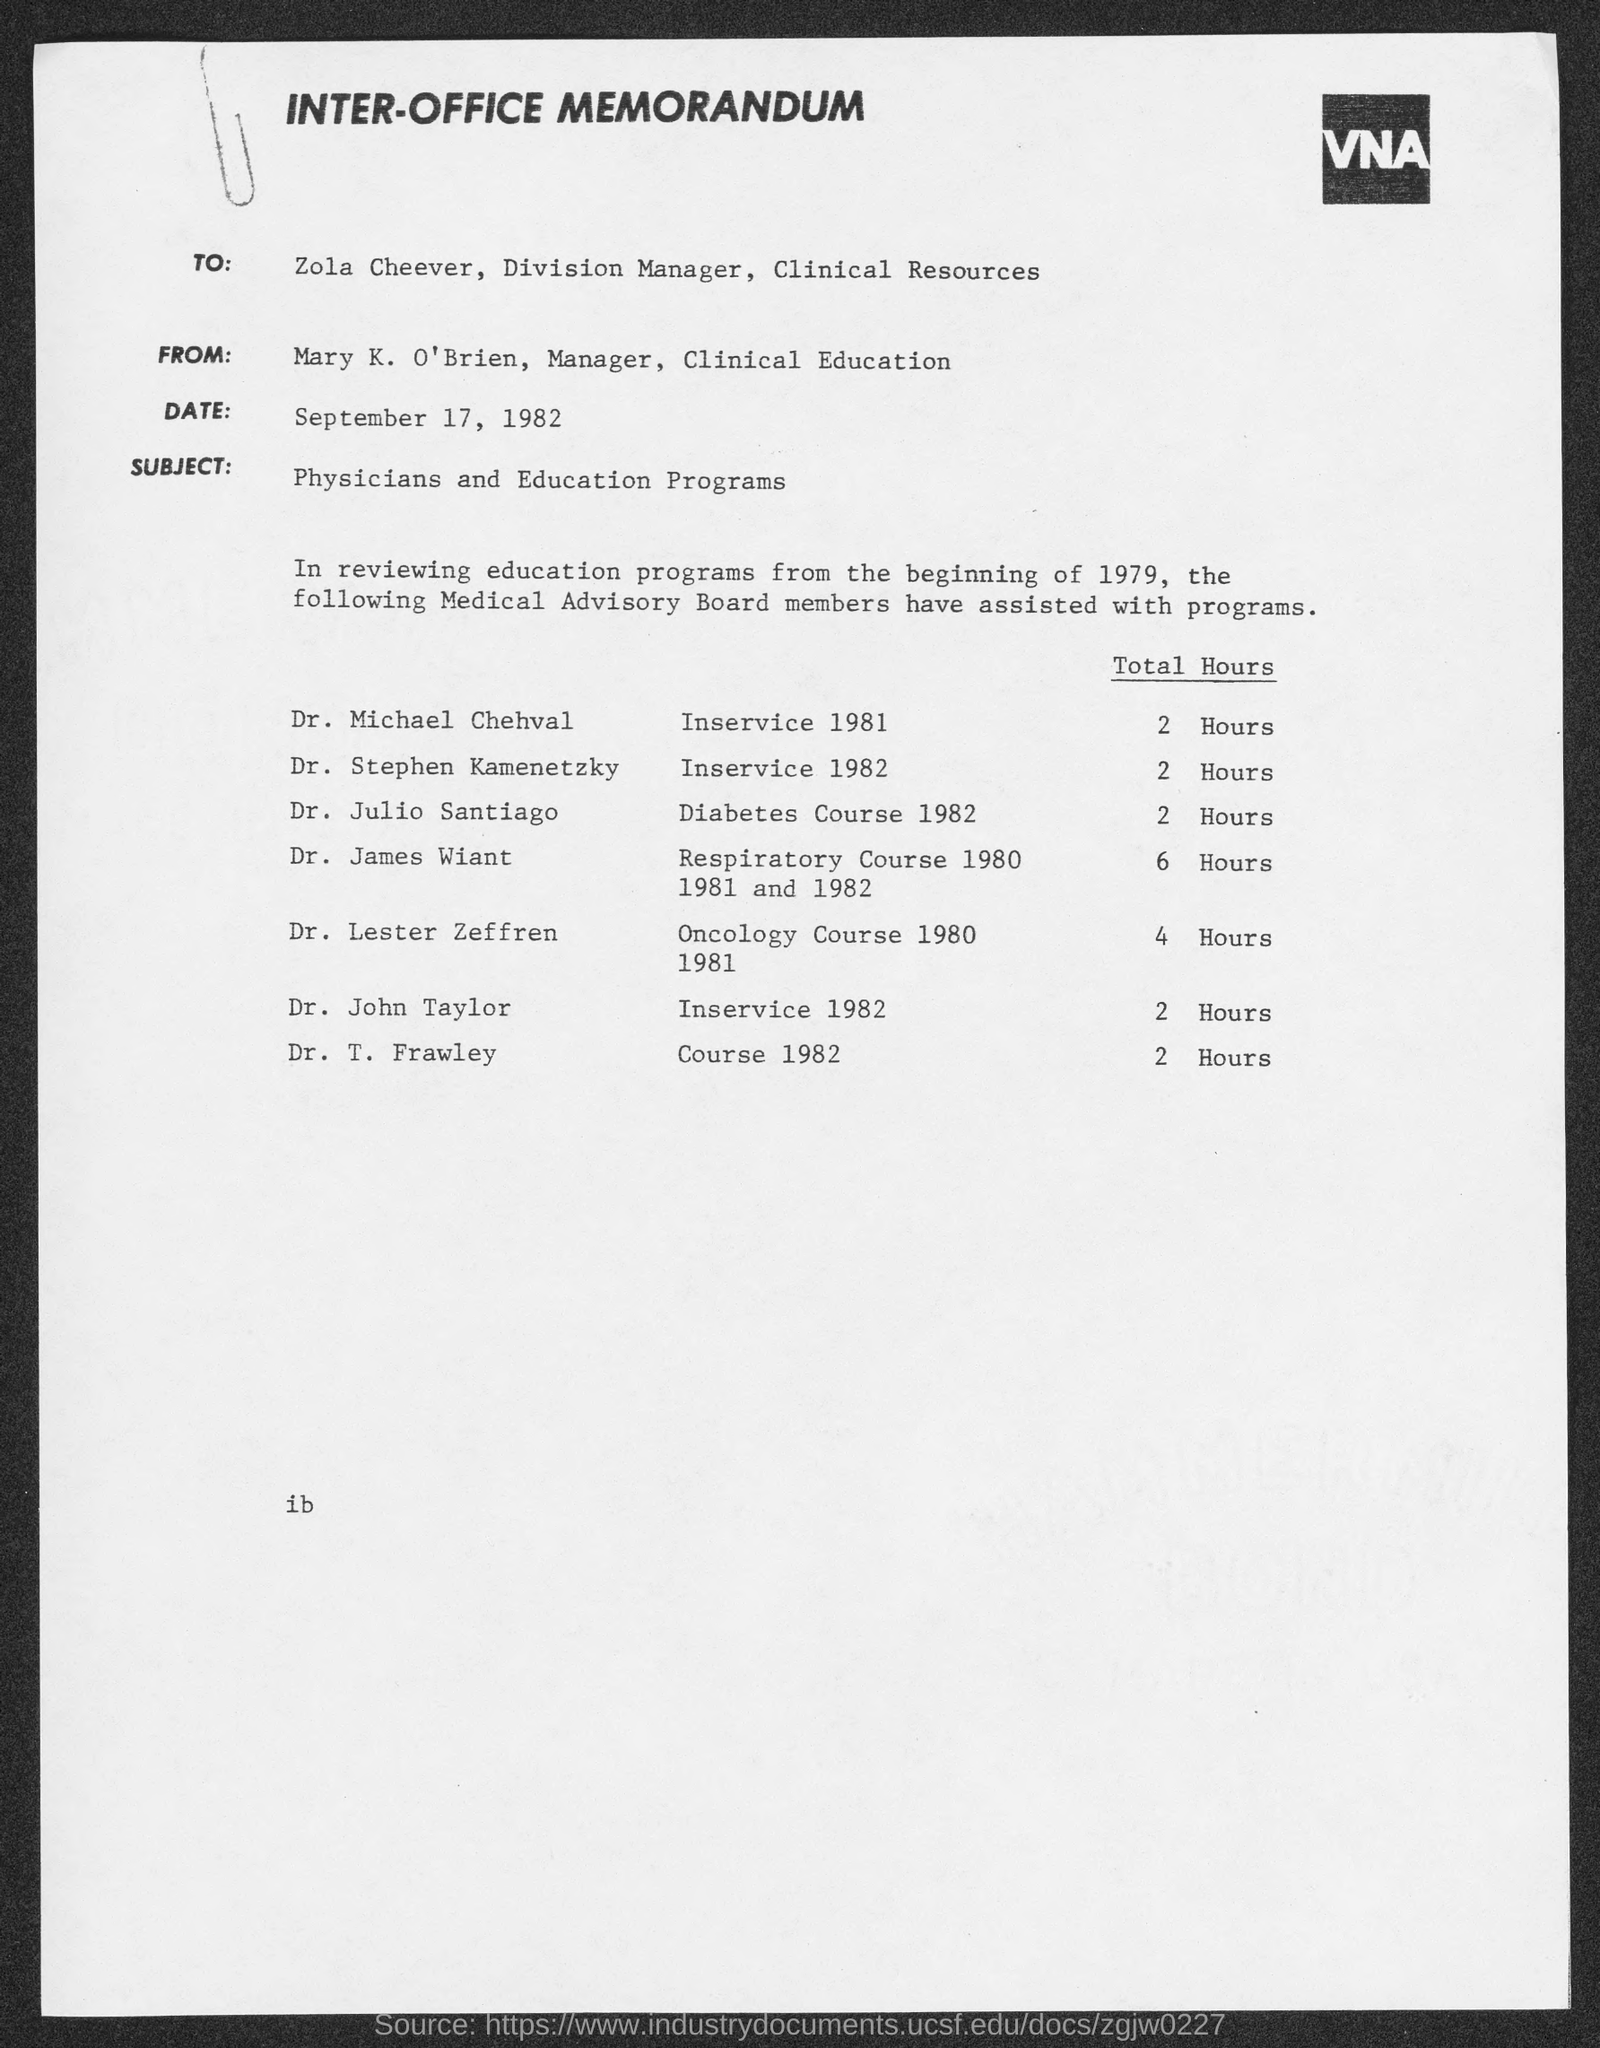What kind of communication is this?
Offer a very short reply. INTER-OFFICE MEMORANDUM. Who is the sender of this memorandum?
Keep it short and to the point. Mary K. O'Brien, Manager, Clinical Education. Who is the addressee of this memorandum?
Offer a terse response. ZOLA CHEEVER, DIVISION MANAGER, CLINICAL RESOURCES. What is the subject mentioned in the memorandum?
Offer a very short reply. Physicians and Education Programs. 